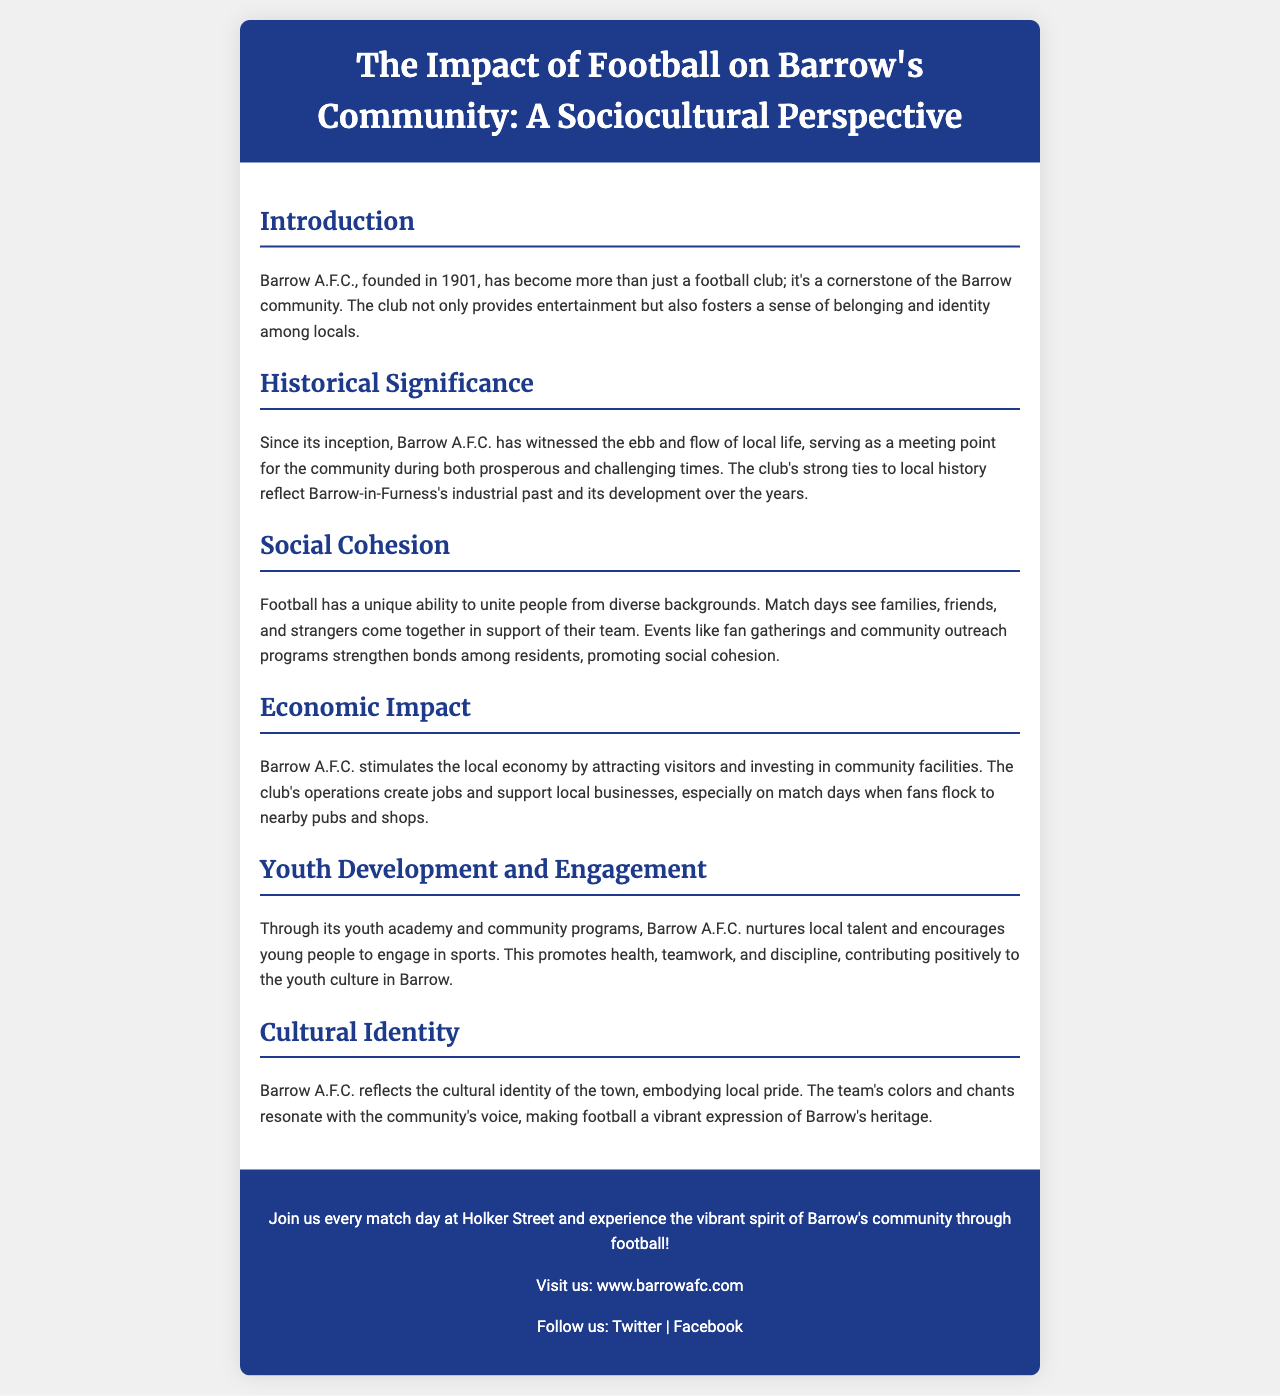What year was Barrow A.F.C. founded? The document states that Barrow A.F.C. was founded in 1901.
Answer: 1901 What is the main purpose of Barrow A.F.C. in the community? The introduction mentions that the club provides entertainment and fosters a sense of belonging and identity among locals.
Answer: Sense of belonging What does the club stimulate in the local community? The economic impact section indicates that Barrow A.F.C. stimulates the local economy.
Answer: Local economy What aspect of life does football unite according to the document? The social cohesion section highlights that football unites people from diverse backgrounds.
Answer: Diverse backgrounds What does the youth academy promote according to the document? The youth development section indicates that the youth academy promotes health, teamwork, and discipline.
Answer: Health, teamwork, and discipline Where can you find Barrow A.F.C. match days? The footer mentions to join at Holker Street for match days.
Answer: Holker Street What is reflected in Barrow A.F.C.'s cultural identity? The cultural identity section states that Barrow A.F.C. embodies local pride.
Answer: Local pride What are the club's colors associated with? The cultural identity section indicates that the team's colors resonate with the community's voice.
Answer: Community's voice 